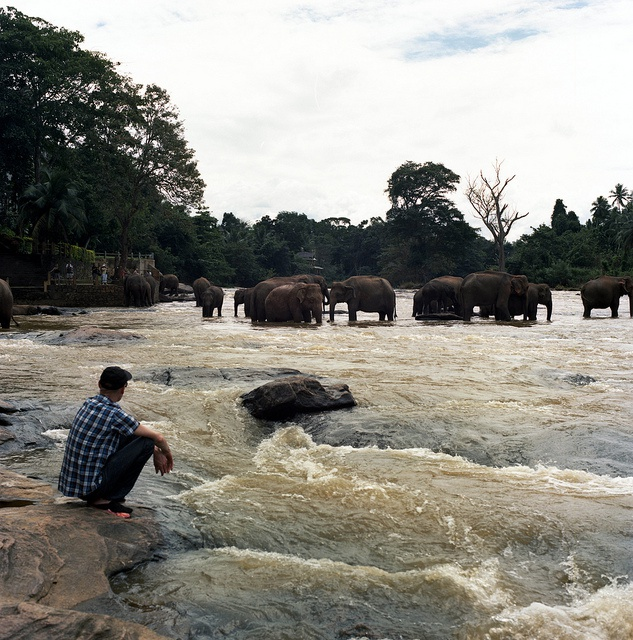Describe the objects in this image and their specific colors. I can see people in white, black, gray, navy, and darkblue tones, elephant in white, black, and gray tones, elephant in white, black, and gray tones, elephant in white, black, gray, and maroon tones, and elephant in white, black, and gray tones in this image. 